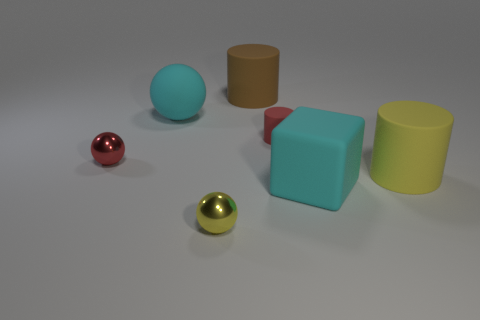How many objects are there in total, and can you describe their colors? There are five objects in total: one red shiny sphere, one light blue cube, one yellow cylinder, one brown cylinder, and one shiny gold sphere. 